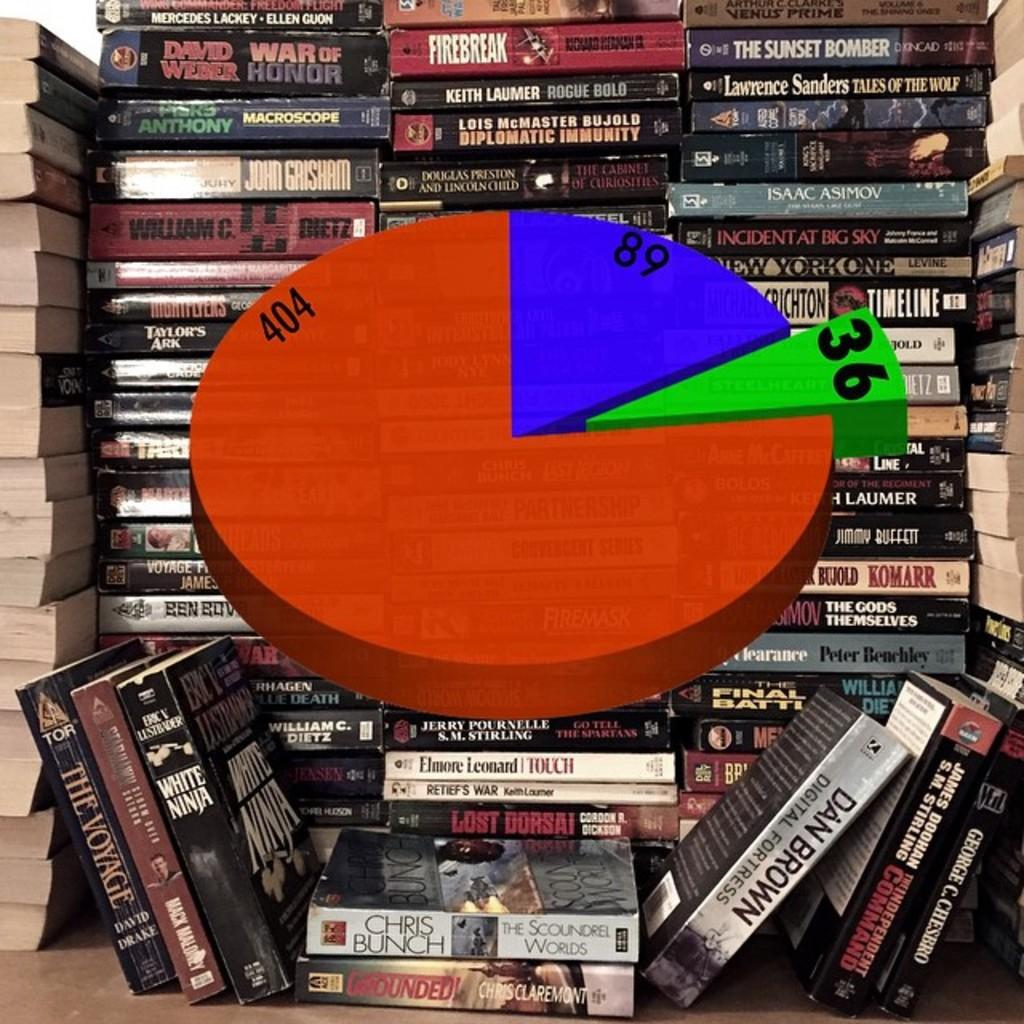What is the main subject in the center of the image? There is a pie diagram in the center of the image. What can be seen in the background of the image? There are books arranged in rows in the background of the image. What type of authority is depicted on the edge of the pie diagram? There is no authority depicted on the edge of the pie diagram, as it is a graphical representation of data and does not include any figures or symbols representing authority. 